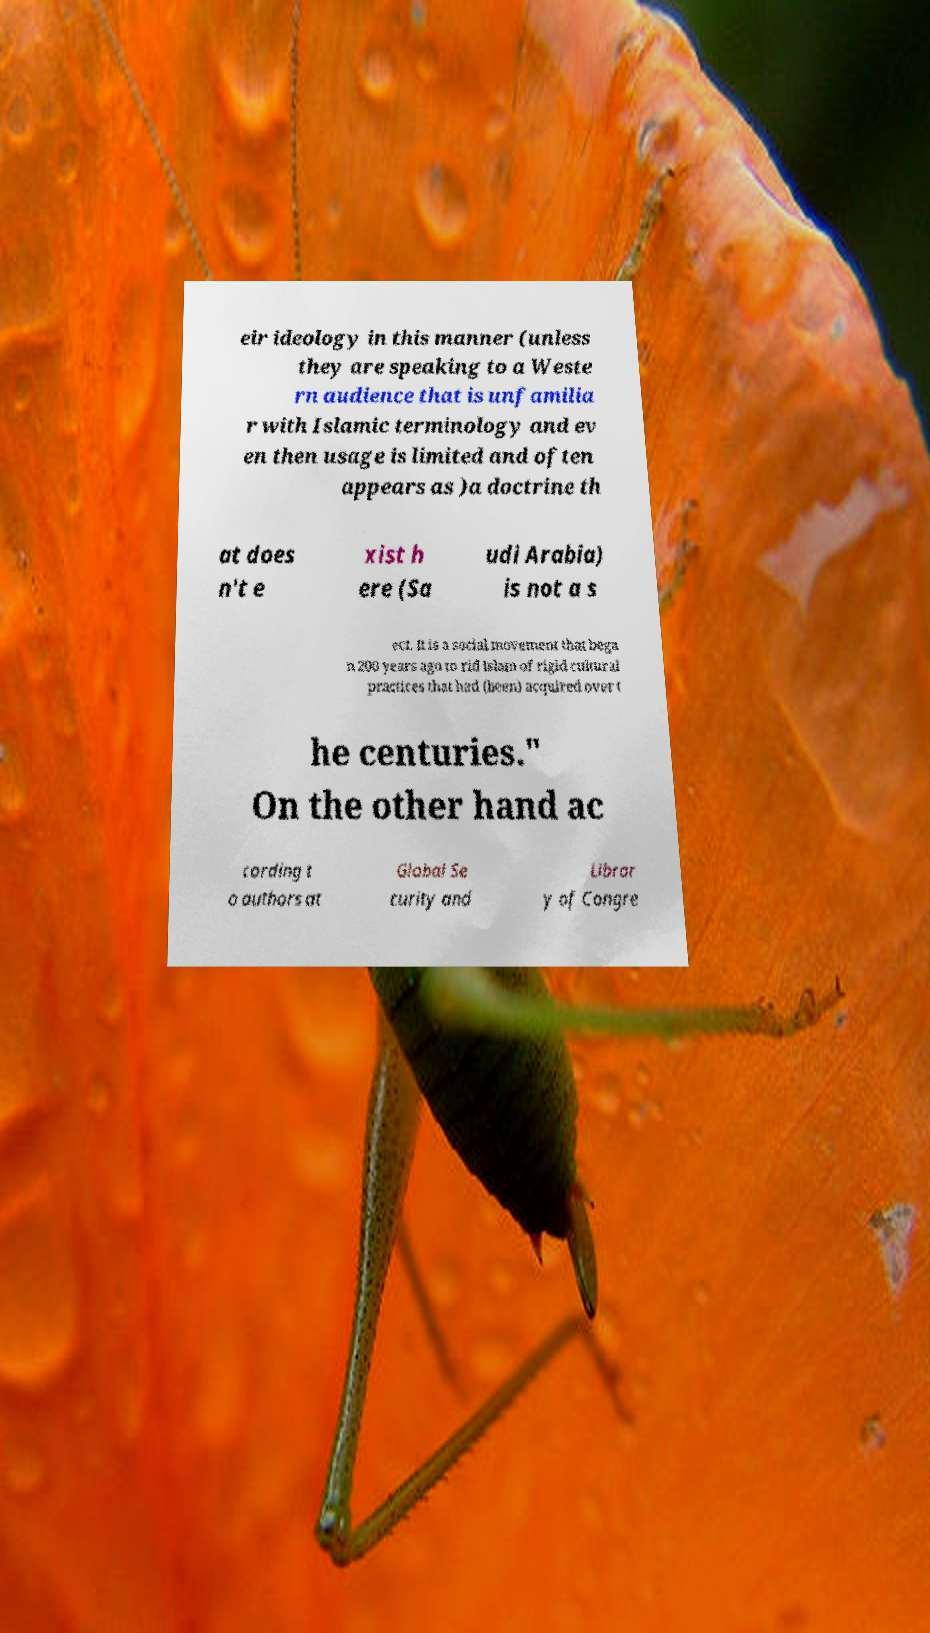Could you extract and type out the text from this image? eir ideology in this manner (unless they are speaking to a Weste rn audience that is unfamilia r with Islamic terminology and ev en then usage is limited and often appears as )a doctrine th at does n't e xist h ere (Sa udi Arabia) is not a s ect. It is a social movement that bega n 200 years ago to rid Islam of rigid cultural practices that had (been) acquired over t he centuries." On the other hand ac cording t o authors at Global Se curity and Librar y of Congre 